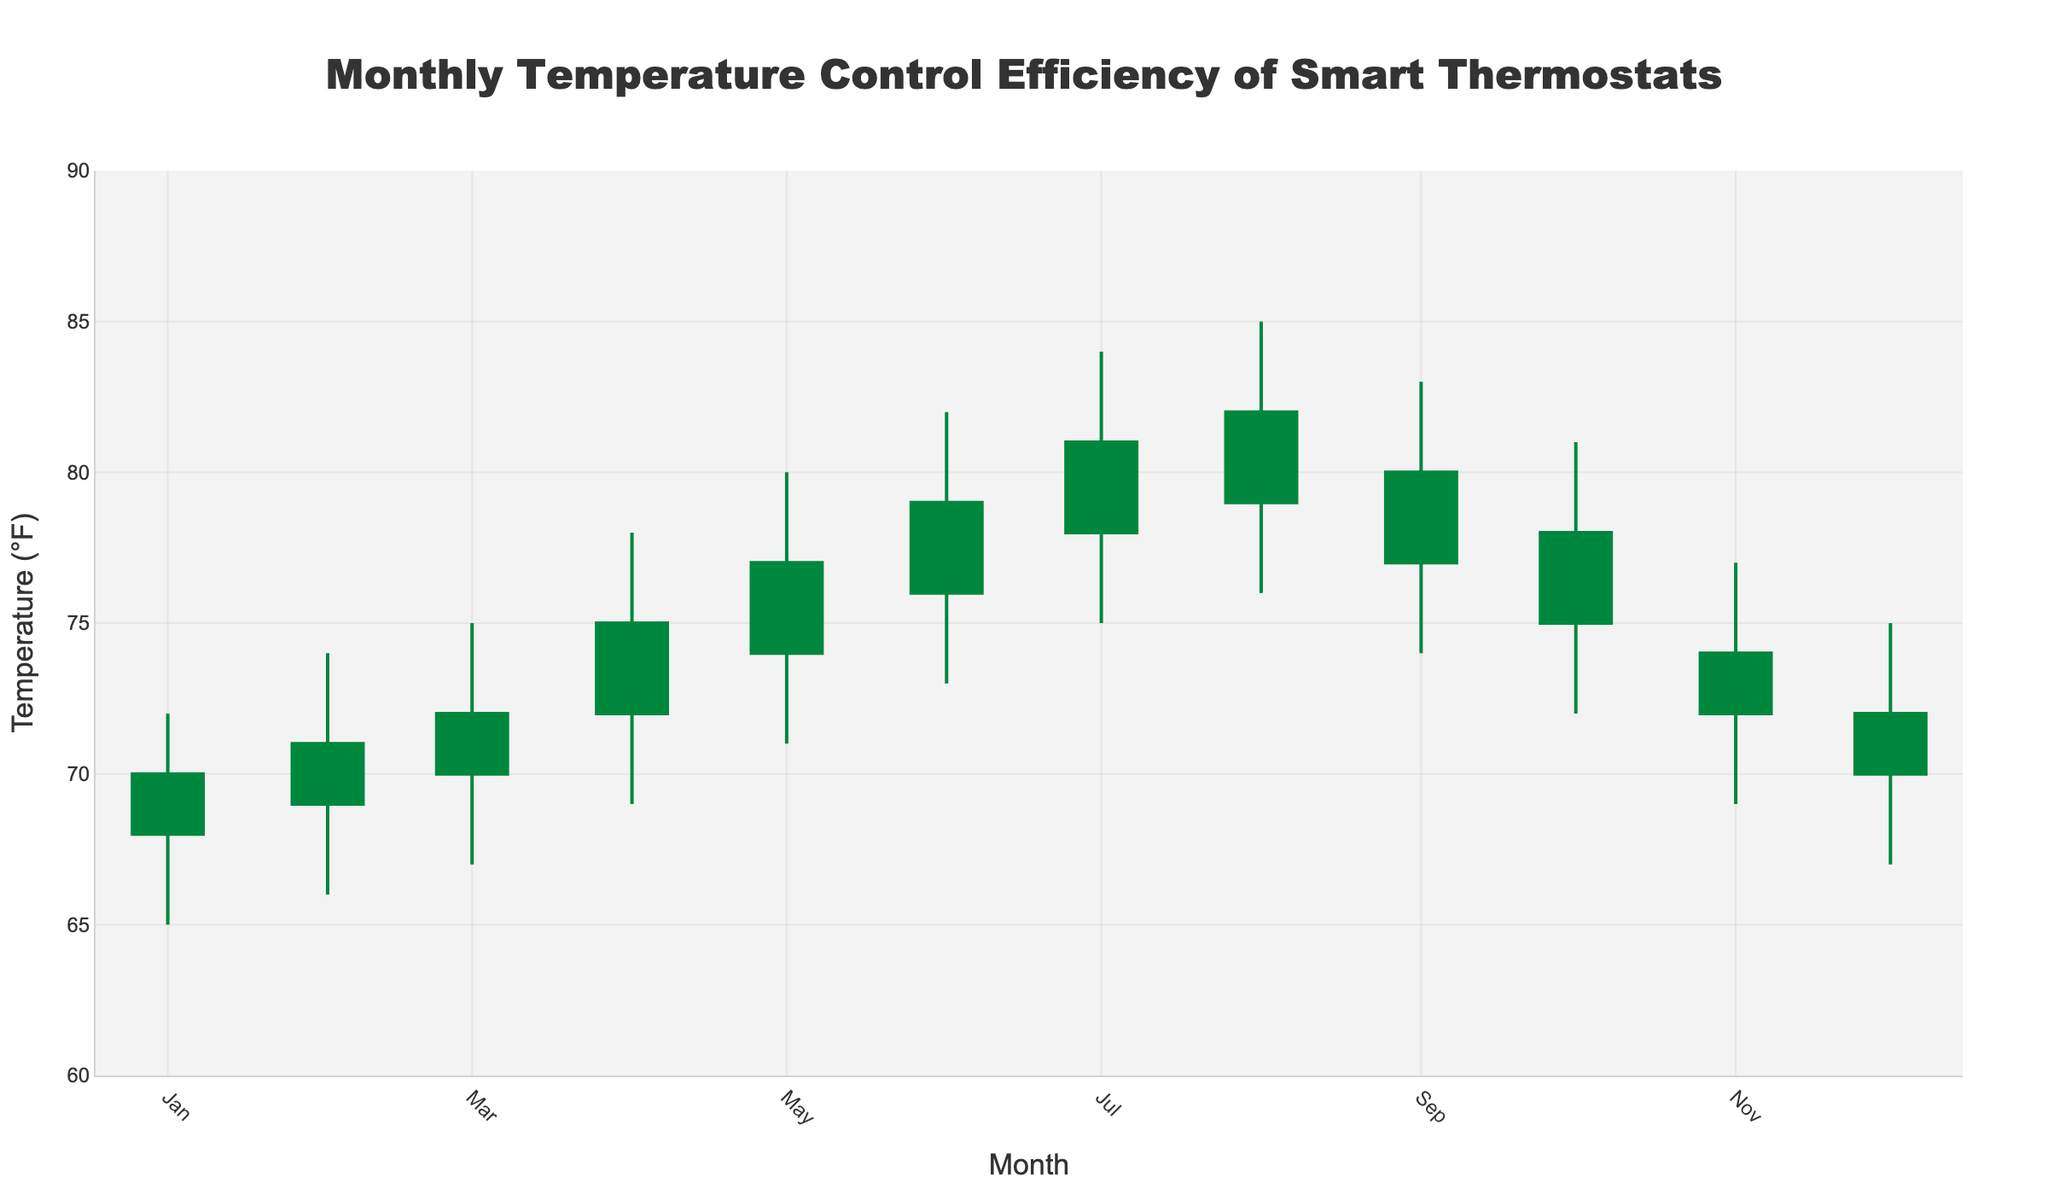What's the title of the figure? The title of the figure is displayed prominently at the top. It's "Monthly Temperature Control Efficiency of Smart Thermostats".
Answer: Monthly Temperature Control Efficiency of Smart Thermostats What is the range of temperatures shown on the y-axis? The range of temperatures can be seen along the y-axis, with the lowest value at 60°F and the highest value at 90°F.
Answer: 60°F to 90°F Which month has the highest high value for temperature? By examining the candlesticks, August has the highest peak value for temperature, reaching up to 85°F.
Answer: August How many months have a closing temperature higher than the opening temperature? To determine this, count the number of candlesticks where the close price (top of the body if the candlestick is green, bottom if red) is above the open price (bottom of the body if green, top if red). There are 11 such months.
Answer: 11 Which month shows the largest increase in temperature from open to close? The largest increase can be identified where the difference between the close and open prices is the greatest. April shows an increase from 72°F to 75°F, a rise of 3°F.
Answer: April What is the difference between the highest high and the lowest low temperatures? Subtract the lowest low temperature from the highest high temperature. The highest high is 85°F (August), and the lowest low is 65°F (January), giving a difference of 20°F.
Answer: 20°F Which months have the same opening and closing temperatures? Look at the candlesticks to see where the open and close prices are equal. December has the same opening and closing temperature of 72°F.
Answer: December Which month shows the highest variability in temperature between low and high? Variability can be measured by the range (difference) between the high and low temperatures. August has the largest range (85°F - 76°F = 9°F).
Answer: August What can you infer about the performance of smart thermostats during the summer months? By examining June, July, and August, we see high temperatures with August showing the highest peak. This suggests that smart thermostats handle higher cooling demands during these months effectively.
Answer: High cooling demand handled Between which consecutive months is the largest drop in closing temperature observed? Identify the largest drop by subtracting the closing temperature of the previous month from the current month's closing temperature. The largest drop is between August (82°F) and September (80°F), a decrease of 2°F.
Answer: August to September 